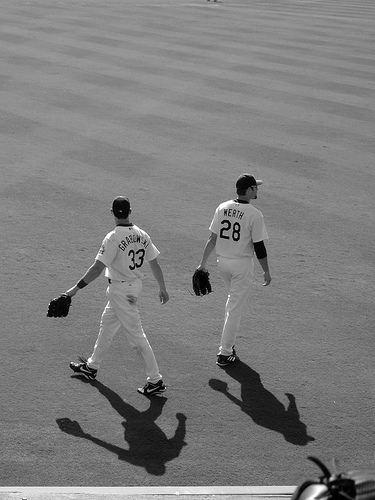What is the atmosphere like in the photo? The photo is in black and white, casting a classic, timeless feel over the image. The shadows are long and dramatic, suggesting that the photo was taken either in the early morning or late afternoon. There is a sense of calm focus, as the players appear to be walking with purpose, possibly getting ready for play or discussing strategy. 